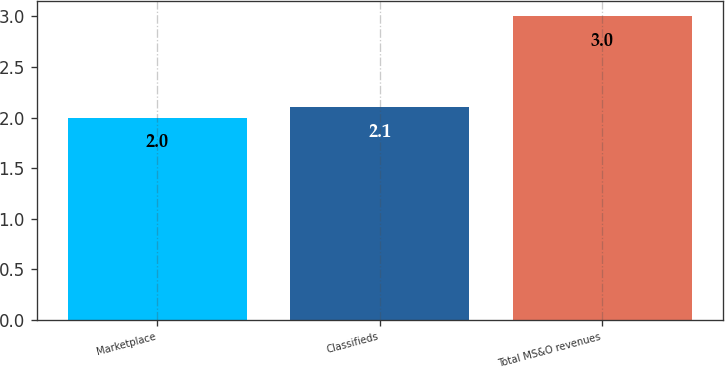Convert chart. <chart><loc_0><loc_0><loc_500><loc_500><bar_chart><fcel>Marketplace<fcel>Classifieds<fcel>Total MS&O revenues<nl><fcel>2<fcel>2.1<fcel>3<nl></chart> 